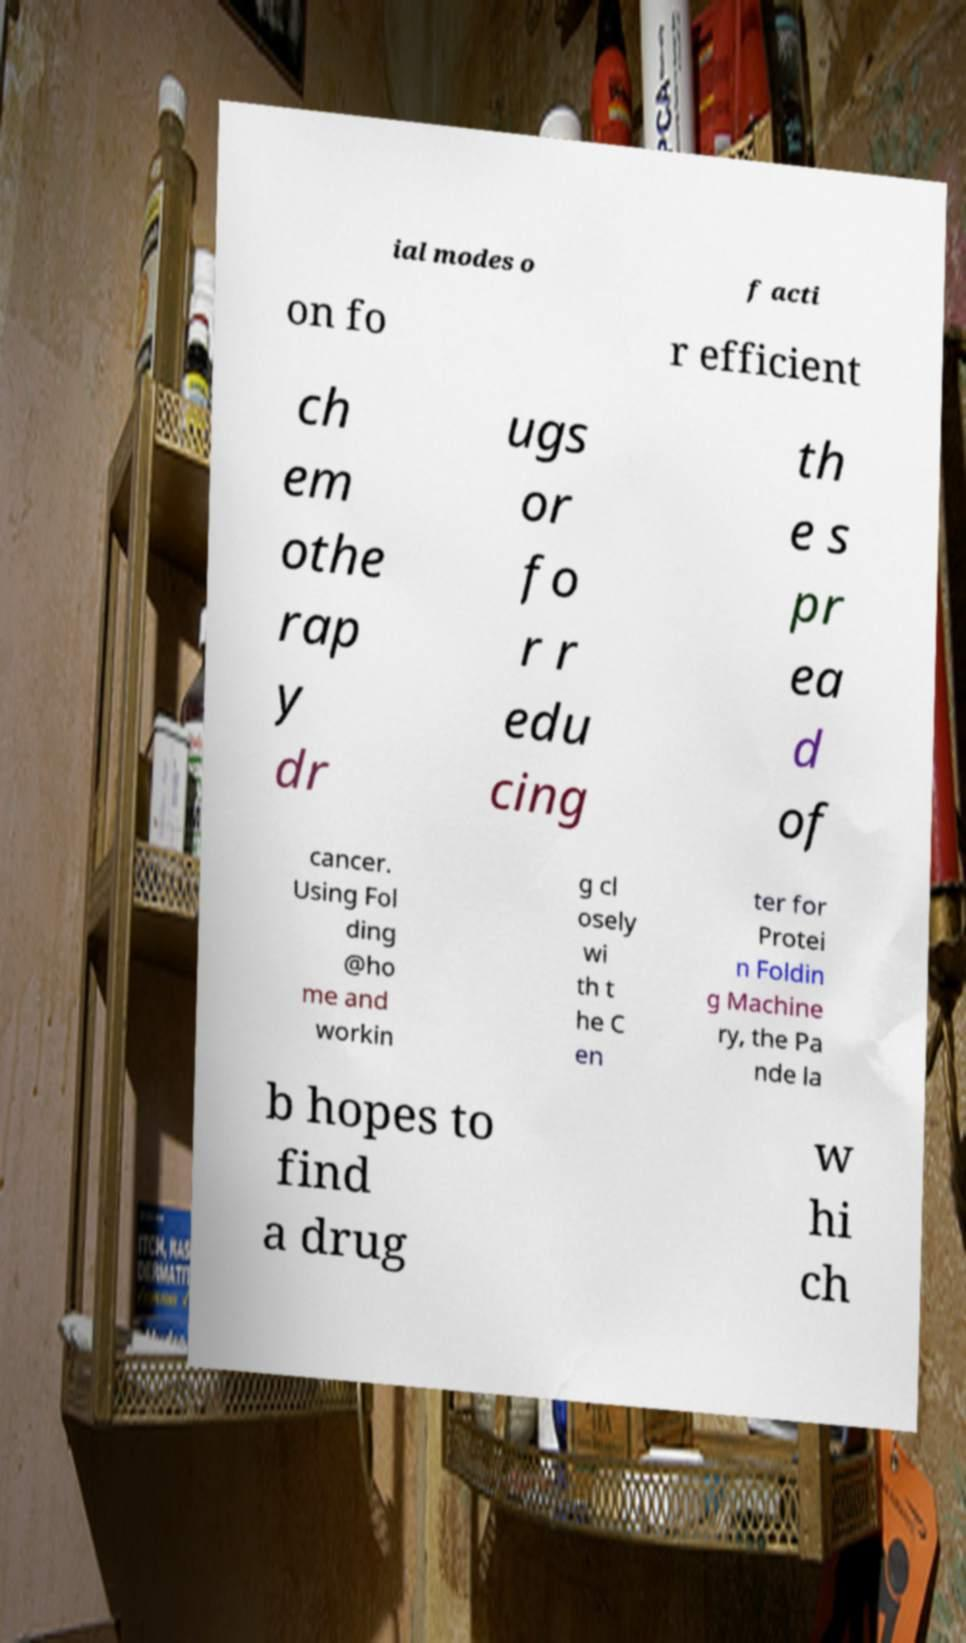What messages or text are displayed in this image? I need them in a readable, typed format. ial modes o f acti on fo r efficient ch em othe rap y dr ugs or fo r r edu cing th e s pr ea d of cancer. Using Fol ding @ho me and workin g cl osely wi th t he C en ter for Protei n Foldin g Machine ry, the Pa nde la b hopes to find a drug w hi ch 